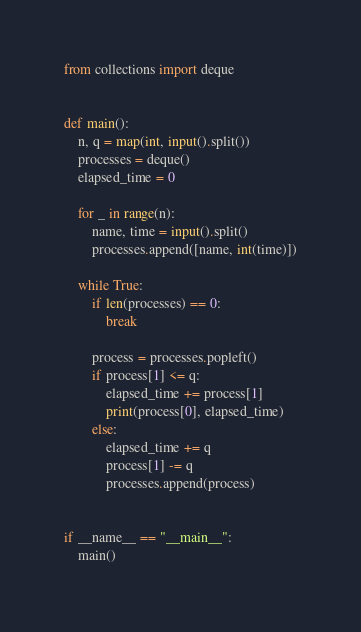<code> <loc_0><loc_0><loc_500><loc_500><_Python_>from collections import deque


def main():
    n, q = map(int, input().split())
    processes = deque()
    elapsed_time = 0

    for _ in range(n):
        name, time = input().split()
        processes.append([name, int(time)])

    while True:
        if len(processes) == 0:
            break

        process = processes.popleft()
        if process[1] <= q:
            elapsed_time += process[1]
            print(process[0], elapsed_time)
        else:
            elapsed_time += q
            process[1] -= q
            processes.append(process)


if __name__ == "__main__":
    main()

</code> 